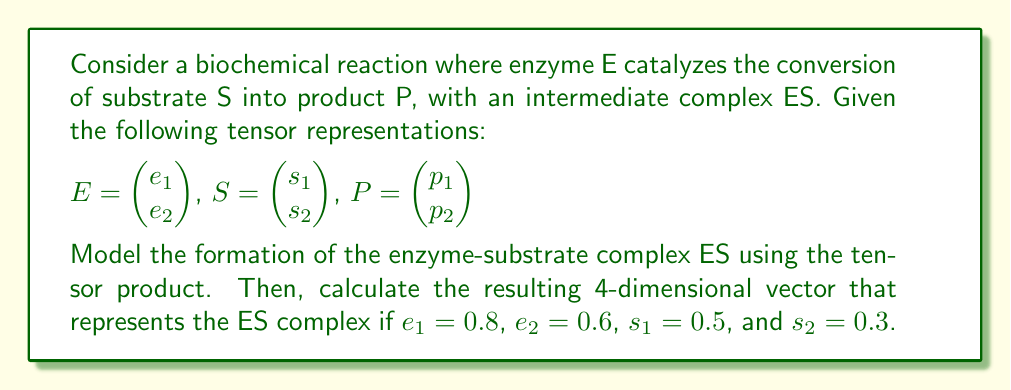Can you solve this math problem? To model the formation of the enzyme-substrate complex ES using tensor products, we follow these steps:

1) The tensor product of E and S is defined as:

   $$ES = E \otimes S = \begin{pmatrix} e_1s_1 \\ e_1s_2 \\ e_2s_1 \\ e_2s_2 \end{pmatrix}$$

2) This results in a 4-dimensional vector that represents all possible interactions between the components of E and S.

3) Given the values:
   $e_1 = 0.8$, $e_2 = 0.6$, $s_1 = 0.5$, and $s_2 = 0.3$

4) We can now calculate each component of the ES complex:

   $e_1s_1 = 0.8 \times 0.5 = 0.40$
   $e_1s_2 = 0.8 \times 0.3 = 0.24$
   $e_2s_1 = 0.6 \times 0.5 = 0.30$
   $e_2s_2 = 0.6 \times 0.3 = 0.18$

5) Therefore, the resulting 4-dimensional vector representing the ES complex is:

   $$ES = \begin{pmatrix} 0.40 \\ 0.24 \\ 0.30 \\ 0.18 \end{pmatrix}$$

This tensor product model captures all possible pairwise interactions between the enzyme and substrate components, which is crucial for understanding the formation of the enzyme-substrate complex in biochemical reactions.
Answer: $$\begin{pmatrix} 0.40 \\ 0.24 \\ 0.30 \\ 0.18 \end{pmatrix}$$ 